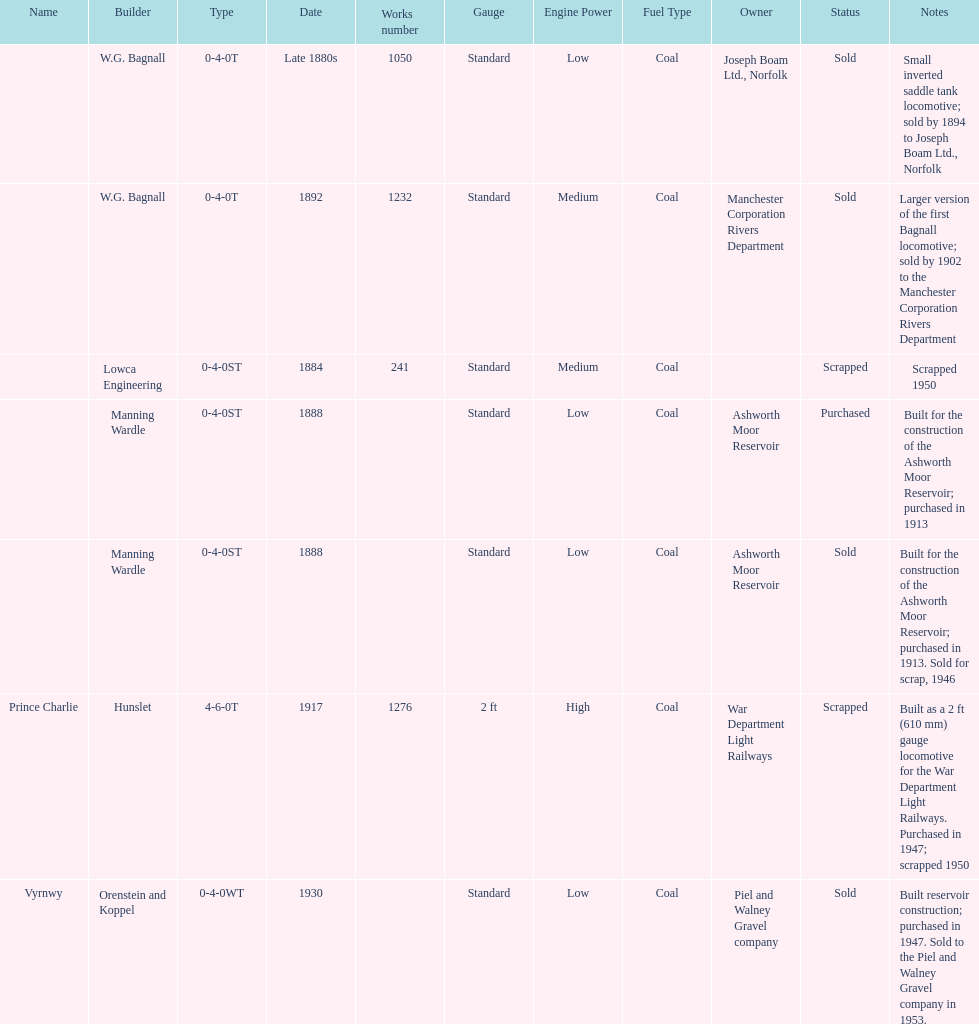List each of the builder's that had a locomotive scrapped. Lowca Engineering, Manning Wardle, Hunslet. 